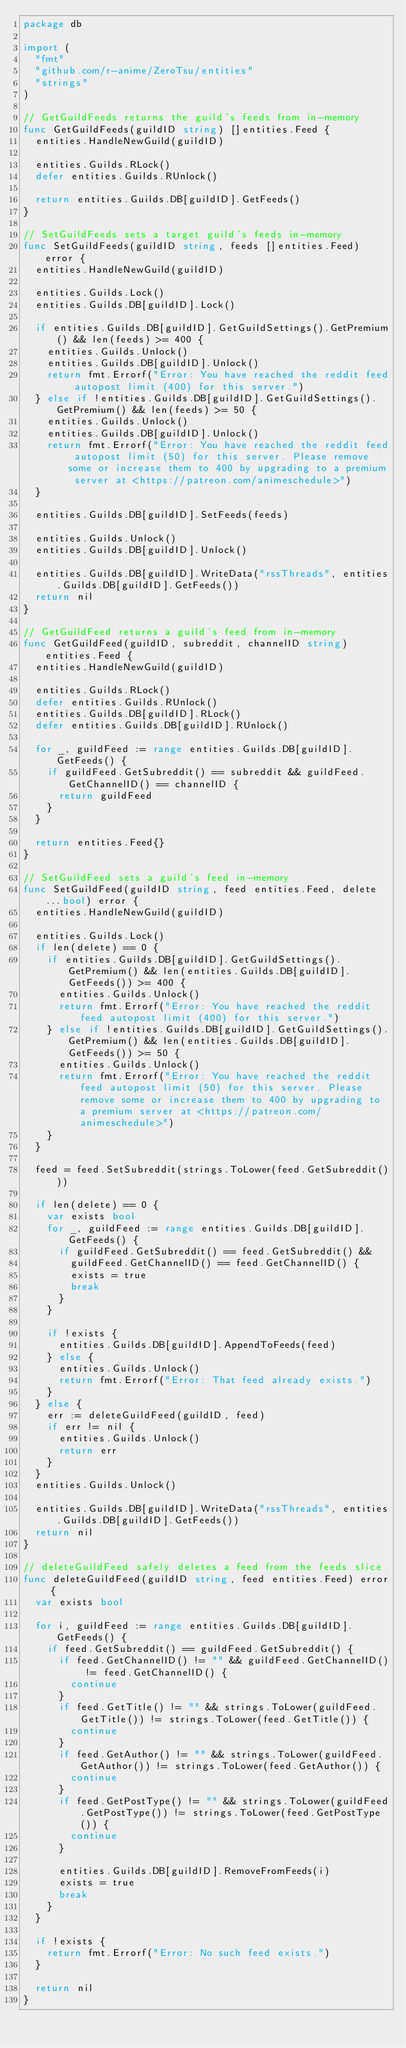<code> <loc_0><loc_0><loc_500><loc_500><_Go_>package db

import (
	"fmt"
	"github.com/r-anime/ZeroTsu/entities"
	"strings"
)

// GetGuildFeeds returns the guild's feeds from in-memory
func GetGuildFeeds(guildID string) []entities.Feed {
	entities.HandleNewGuild(guildID)

	entities.Guilds.RLock()
	defer entities.Guilds.RUnlock()

	return entities.Guilds.DB[guildID].GetFeeds()
}

// SetGuildFeeds sets a target guild's feeds in-memory
func SetGuildFeeds(guildID string, feeds []entities.Feed) error {
	entities.HandleNewGuild(guildID)

	entities.Guilds.Lock()
	entities.Guilds.DB[guildID].Lock()

	if entities.Guilds.DB[guildID].GetGuildSettings().GetPremium() && len(feeds) >= 400 {
		entities.Guilds.Unlock()
		entities.Guilds.DB[guildID].Unlock()
		return fmt.Errorf("Error: You have reached the reddit feed autopost limit (400) for this server.")
	} else if !entities.Guilds.DB[guildID].GetGuildSettings().GetPremium() && len(feeds) >= 50 {
		entities.Guilds.Unlock()
		entities.Guilds.DB[guildID].Unlock()
		return fmt.Errorf("Error: You have reached the reddit feed autopost limit (50) for this server. Please remove some or increase them to 400 by upgrading to a premium server at <https://patreon.com/animeschedule>")
	}

	entities.Guilds.DB[guildID].SetFeeds(feeds)

	entities.Guilds.Unlock()
	entities.Guilds.DB[guildID].Unlock()

	entities.Guilds.DB[guildID].WriteData("rssThreads", entities.Guilds.DB[guildID].GetFeeds())
	return nil
}

// GetGuildFeed returns a guild's feed from in-memory
func GetGuildFeed(guildID, subreddit, channelID string) entities.Feed {
	entities.HandleNewGuild(guildID)

	entities.Guilds.RLock()
	defer entities.Guilds.RUnlock()
	entities.Guilds.DB[guildID].RLock()
	defer entities.Guilds.DB[guildID].RUnlock()

	for _, guildFeed := range entities.Guilds.DB[guildID].GetFeeds() {
		if guildFeed.GetSubreddit() == subreddit && guildFeed.GetChannelID() == channelID {
			return guildFeed
		}
	}

	return entities.Feed{}
}

// SetGuildFeed sets a guild's feed in-memory
func SetGuildFeed(guildID string, feed entities.Feed, delete ...bool) error {
	entities.HandleNewGuild(guildID)

	entities.Guilds.Lock()
	if len(delete) == 0 {
		if entities.Guilds.DB[guildID].GetGuildSettings().GetPremium() && len(entities.Guilds.DB[guildID].GetFeeds()) >= 400 {
			entities.Guilds.Unlock()
			return fmt.Errorf("Error: You have reached the reddit feed autopost limit (400) for this server.")
		} else if !entities.Guilds.DB[guildID].GetGuildSettings().GetPremium() && len(entities.Guilds.DB[guildID].GetFeeds()) >= 50 {
			entities.Guilds.Unlock()
			return fmt.Errorf("Error: You have reached the reddit feed autopost limit (50) for this server. Please remove some or increase them to 400 by upgrading to a premium server at <https://patreon.com/animeschedule>")
		}
	}

	feed = feed.SetSubreddit(strings.ToLower(feed.GetSubreddit()))

	if len(delete) == 0 {
		var exists bool
		for _, guildFeed := range entities.Guilds.DB[guildID].GetFeeds() {
			if guildFeed.GetSubreddit() == feed.GetSubreddit() &&
				guildFeed.GetChannelID() == feed.GetChannelID() {
				exists = true
				break
			}
		}

		if !exists {
			entities.Guilds.DB[guildID].AppendToFeeds(feed)
		} else {
			entities.Guilds.Unlock()
			return fmt.Errorf("Error: That feed already exists.")
		}
	} else {
		err := deleteGuildFeed(guildID, feed)
		if err != nil {
			entities.Guilds.Unlock()
			return err
		}
	}
	entities.Guilds.Unlock()

	entities.Guilds.DB[guildID].WriteData("rssThreads", entities.Guilds.DB[guildID].GetFeeds())
	return nil
}

// deleteGuildFeed safely deletes a feed from the feeds slice
func deleteGuildFeed(guildID string, feed entities.Feed) error {
	var exists bool

	for i, guildFeed := range entities.Guilds.DB[guildID].GetFeeds() {
		if feed.GetSubreddit() == guildFeed.GetSubreddit() {
			if feed.GetChannelID() != "" && guildFeed.GetChannelID() != feed.GetChannelID() {
				continue
			}
			if feed.GetTitle() != "" && strings.ToLower(guildFeed.GetTitle()) != strings.ToLower(feed.GetTitle()) {
				continue
			}
			if feed.GetAuthor() != "" && strings.ToLower(guildFeed.GetAuthor()) != strings.ToLower(feed.GetAuthor()) {
				continue
			}
			if feed.GetPostType() != "" && strings.ToLower(guildFeed.GetPostType()) != strings.ToLower(feed.GetPostType()) {
				continue
			}

			entities.Guilds.DB[guildID].RemoveFromFeeds(i)
			exists = true
			break
		}
	}

	if !exists {
		return fmt.Errorf("Error: No such feed exists.")
	}

	return nil
}
</code> 